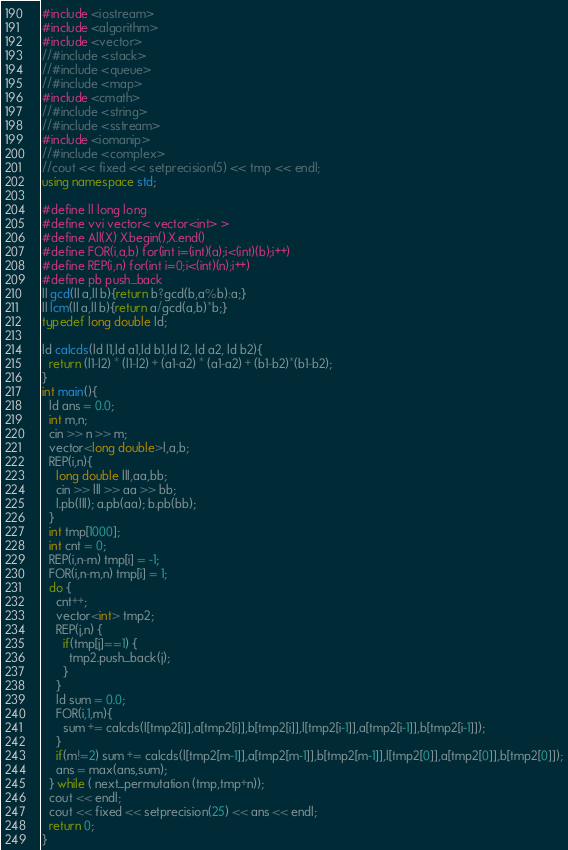<code> <loc_0><loc_0><loc_500><loc_500><_C++_>#include <iostream>
#include <algorithm>
#include <vector>
//#include <stack>
//#include <queue>
//#include <map>
#include <cmath>
//#include <string>
//#include <sstream>
#include <iomanip>
//#include <complex>
//cout << fixed << setprecision(5) << tmp << endl;
using namespace std;

#define ll long long
#define vvi vector< vector<int> >
#define All(X) X.begin(),X.end()
#define FOR(i,a,b) for(int i=(int)(a);i<(int)(b);i++)
#define REP(i,n) for(int i=0;i<(int)(n);i++)
#define pb push_back 
ll gcd(ll a,ll b){return b?gcd(b,a%b):a;}
ll lcm(ll a,ll b){return a/gcd(a,b)*b;}
typedef long double ld;

ld calcds(ld l1,ld a1,ld b1,ld l2, ld a2, ld b2){
  return (l1-l2) * (l1-l2) + (a1-a2) * (a1-a2) + (b1-b2)*(b1-b2);
}
int main(){
  ld ans = 0.0;
  int m,n;
  cin >> n >> m;
  vector<long double>l,a,b;
  REP(i,n){
    long double lll,aa,bb;
    cin >> lll >> aa >> bb;
    l.pb(lll); a.pb(aa); b.pb(bb);
  }
  int tmp[1000];
  int cnt = 0;
  REP(i,n-m) tmp[i] = -1;
  FOR(i,n-m,n) tmp[i] = 1;
  do {
    cnt++;
    vector<int> tmp2;
    REP(j,n) {
      if(tmp[j]==1) {
        tmp2.push_back(j);
      }
    }
    ld sum = 0.0;
    FOR(i,1,m){
      sum += calcds(l[tmp2[i]],a[tmp2[i]],b[tmp2[i]],l[tmp2[i-1]],a[tmp2[i-1]],b[tmp2[i-1]]);
    }
    if(m!=2) sum += calcds(l[tmp2[m-1]],a[tmp2[m-1]],b[tmp2[m-1]],l[tmp2[0]],a[tmp2[0]],b[tmp2[0]]);
    ans = max(ans,sum);
  } while ( next_permutation (tmp,tmp+n));
  cout << endl;
  cout << fixed << setprecision(25) << ans << endl;
  return 0;
}</code> 